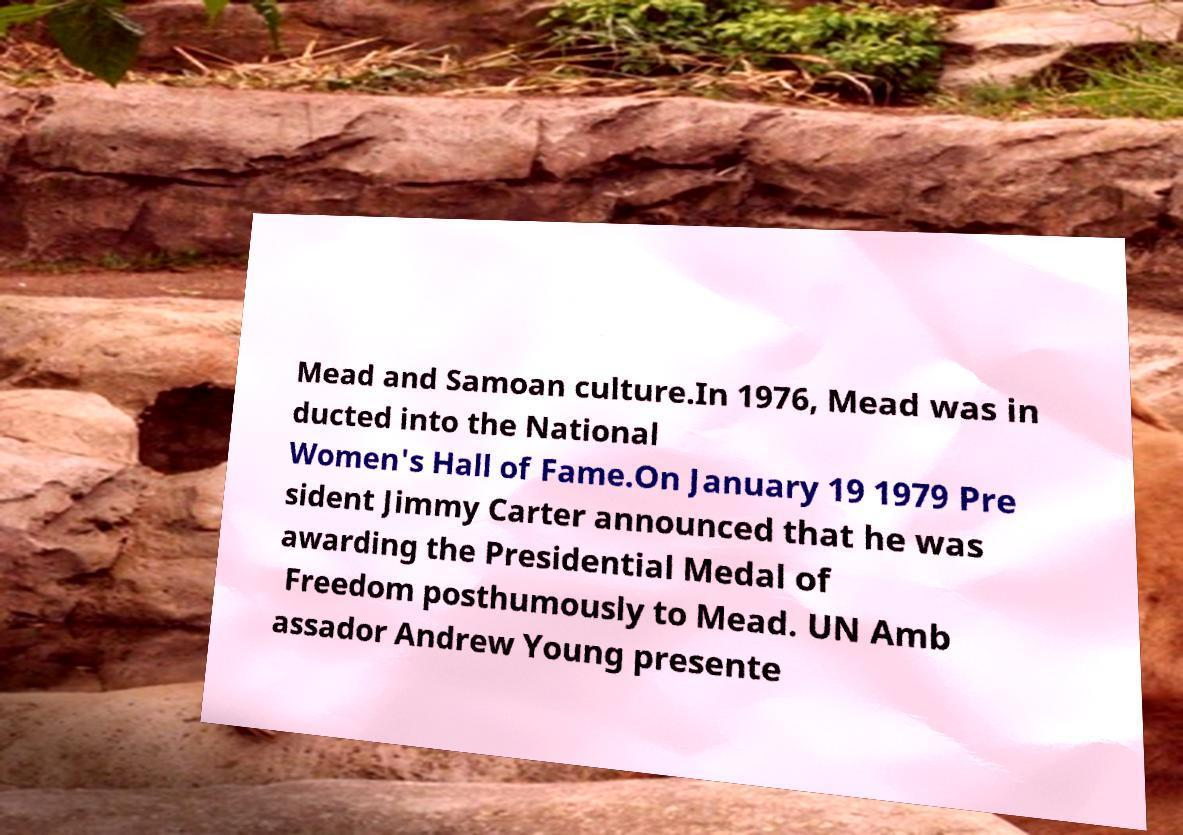What messages or text are displayed in this image? I need them in a readable, typed format. Mead and Samoan culture.In 1976, Mead was in ducted into the National Women's Hall of Fame.On January 19 1979 Pre sident Jimmy Carter announced that he was awarding the Presidential Medal of Freedom posthumously to Mead. UN Amb assador Andrew Young presente 